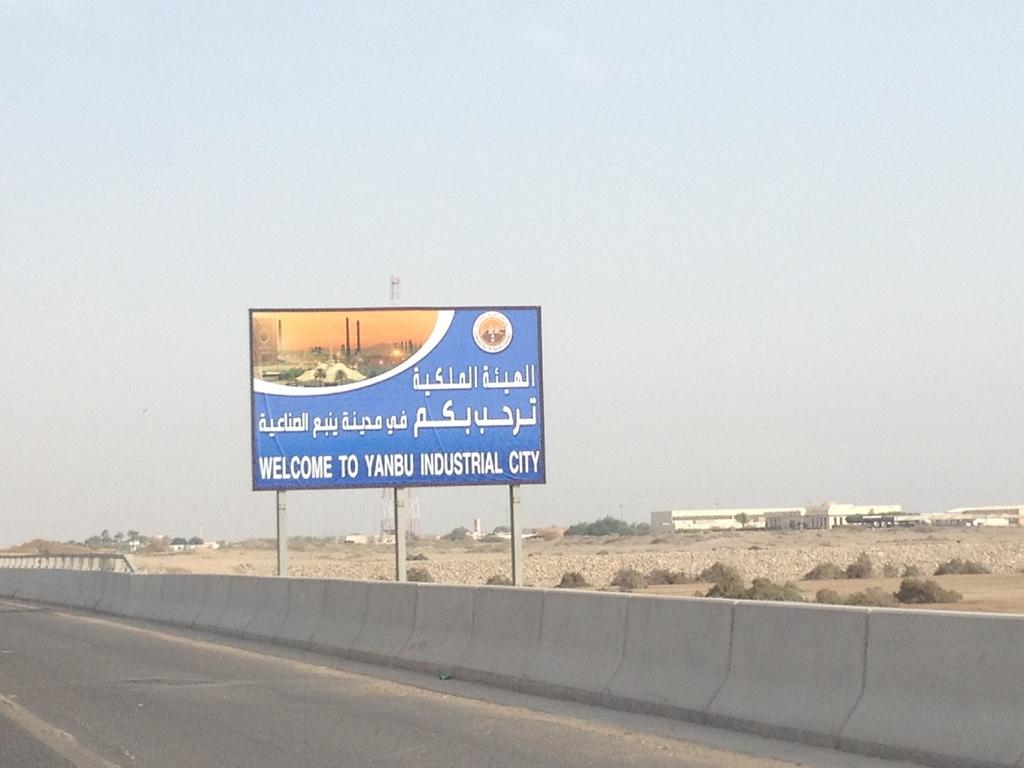<image>
Render a clear and concise summary of the photo. A billboard along the highway reads in English and Arabic Welcome to Yanbu Industrial City 